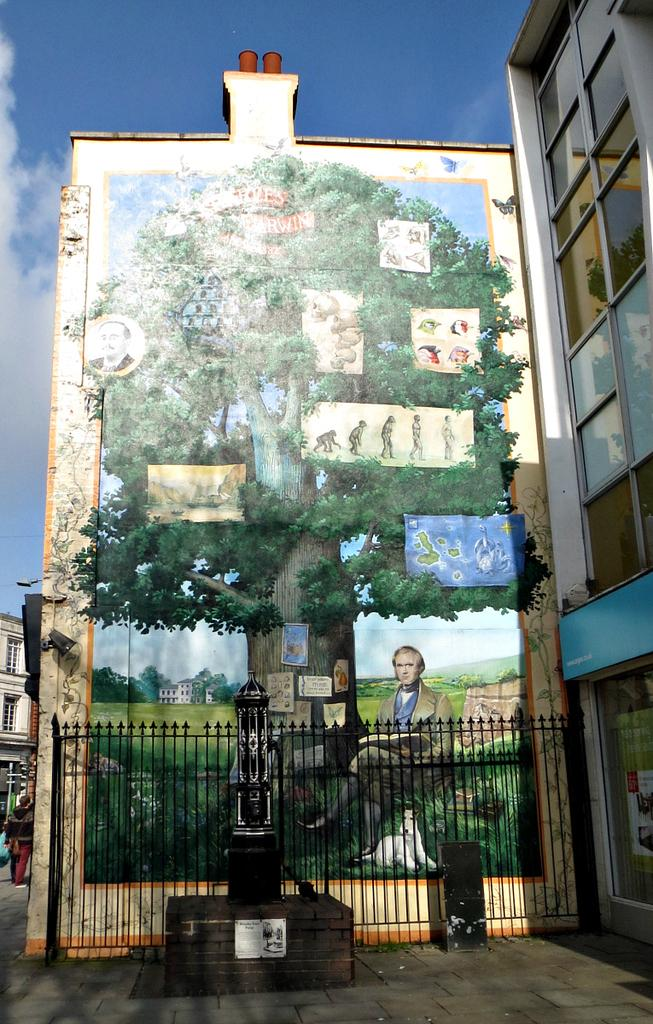What type of structures can be seen in the image? There are buildings in the image. What feature do the buildings have? The buildings have glass windows. What other notable object is present in the image? There is a statue in the image. What type of barrier is visible in the image? There is fencing in the image. How many paintings can be seen in the image? There are three paintings in the image: one of a person, one of a dog, and one of a tree. What can be seen in the sky in the image? The sky is visible in the image and has a white and blue color. What type of collar is the dog wearing in the painting? There is no dog wearing a collar in the painting, as the painting depicts a dog without a collar. What type of meat is being served at the event in the image? There is no event or meat present in the image; it features buildings, a statue, fencing, and paintings. 